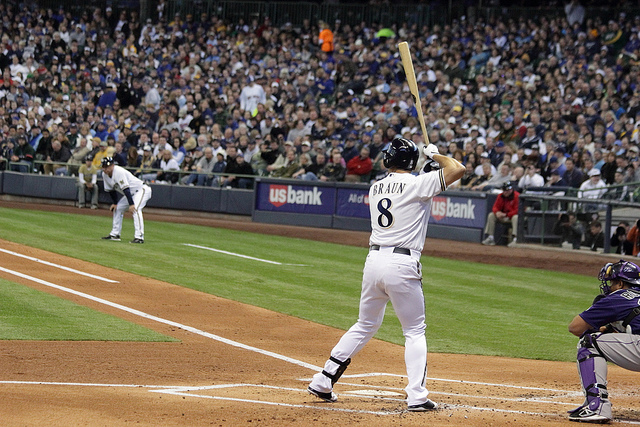How many people can be seen? In the image, four individuals are clearly visible. There's a batter ready to swing at home plate, the catcher and umpire crouched behind him, and a pitcher in the midst of a throw on the mound. 